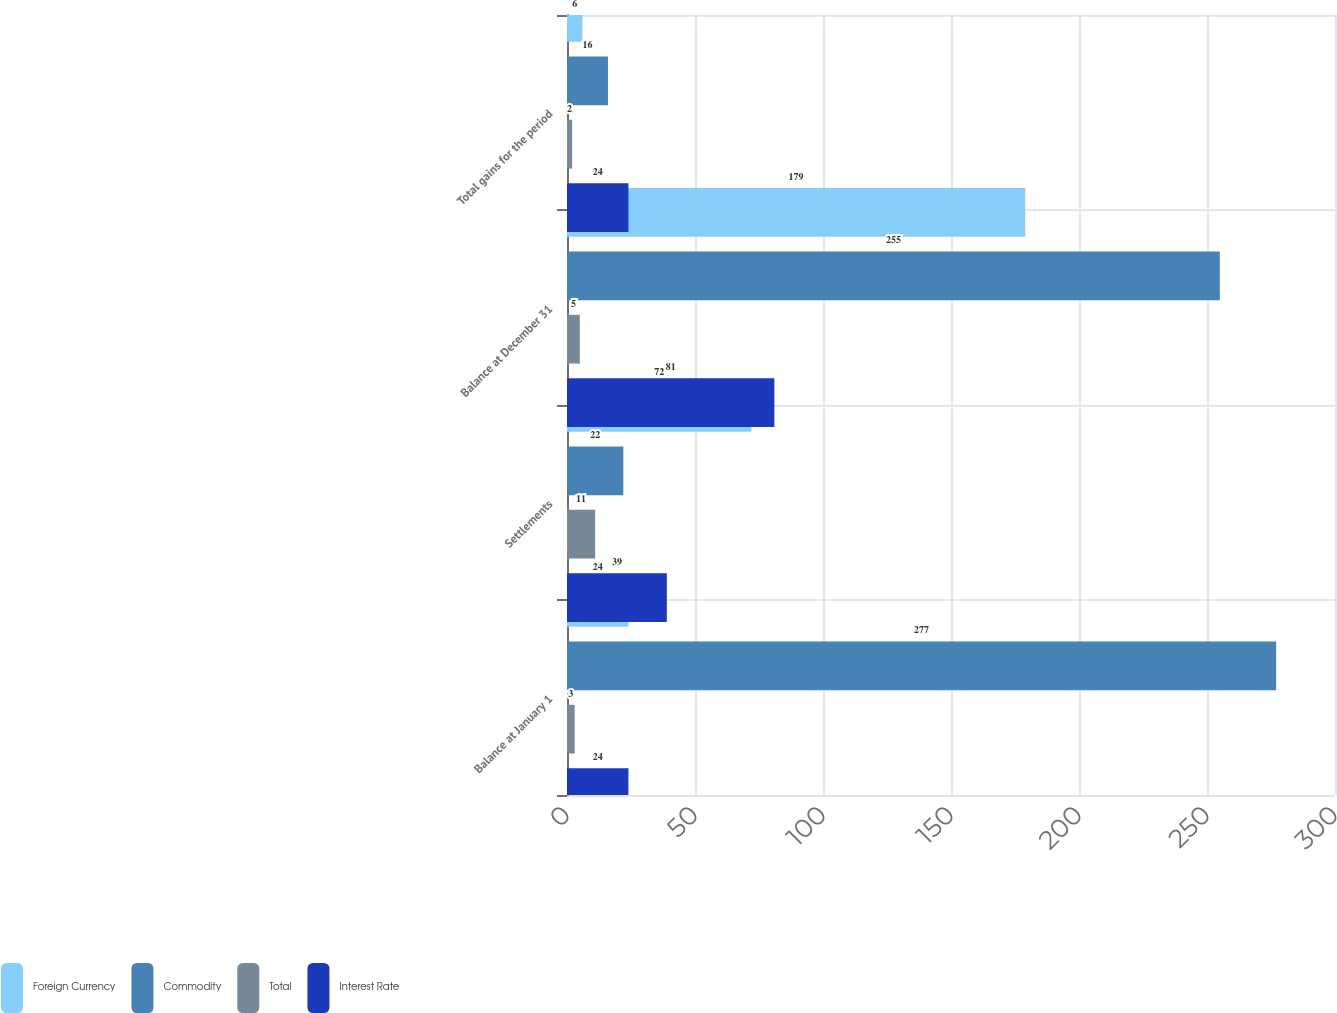Convert chart. <chart><loc_0><loc_0><loc_500><loc_500><stacked_bar_chart><ecel><fcel>Balance at January 1<fcel>Settlements<fcel>Balance at December 31<fcel>Total gains for the period<nl><fcel>Foreign Currency<fcel>24<fcel>72<fcel>179<fcel>6<nl><fcel>Commodity<fcel>277<fcel>22<fcel>255<fcel>16<nl><fcel>Total<fcel>3<fcel>11<fcel>5<fcel>2<nl><fcel>Interest Rate<fcel>24<fcel>39<fcel>81<fcel>24<nl></chart> 